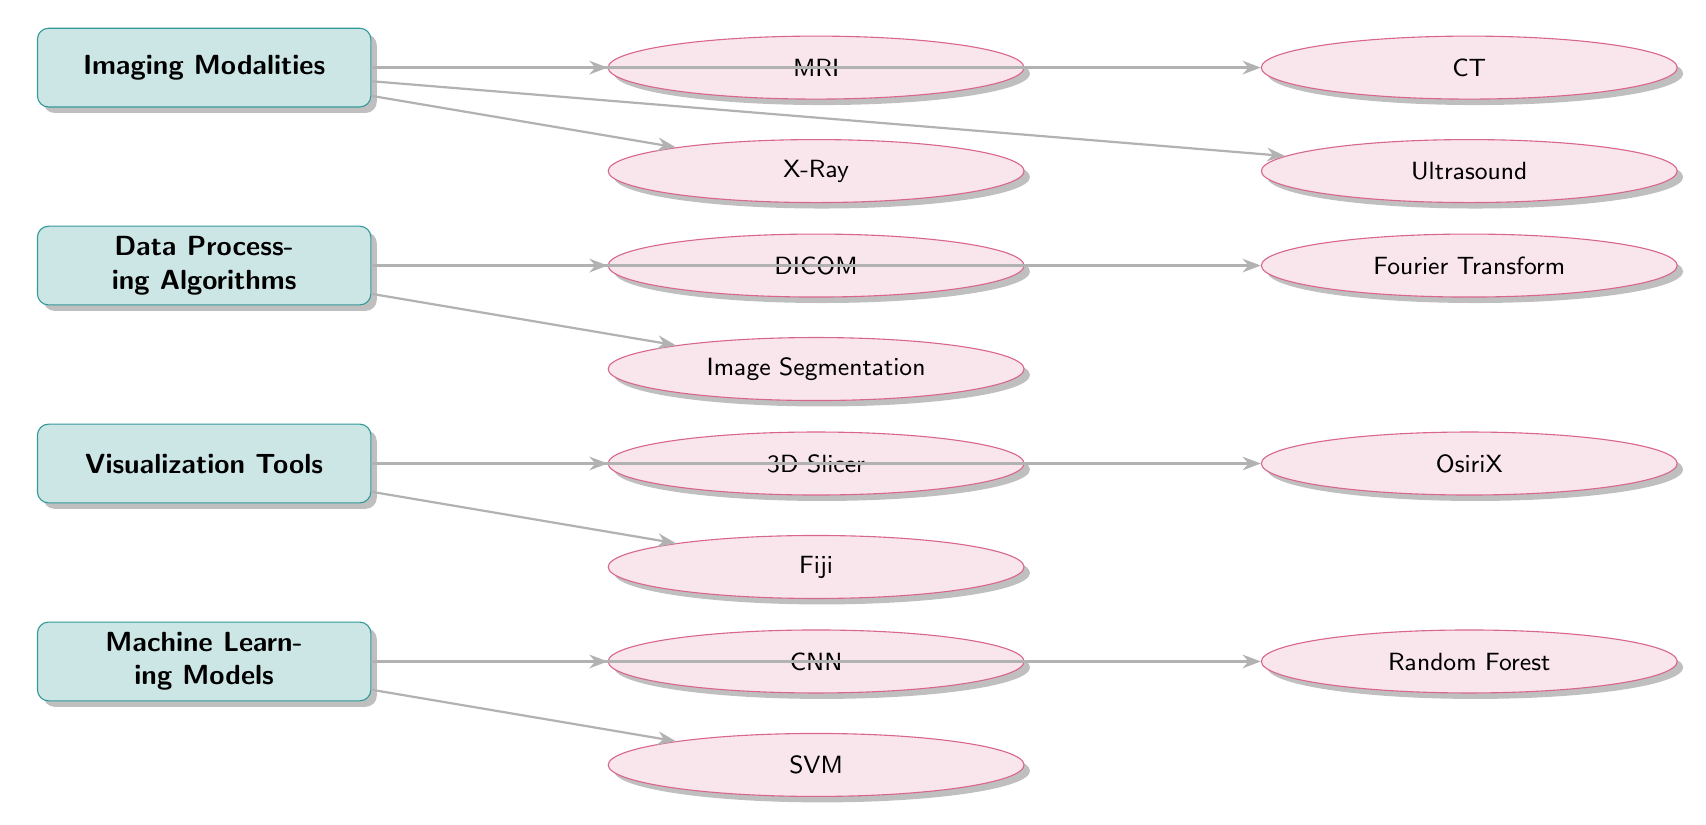What are the imaging modalities listed in the diagram? The diagram identifies four imaging modalities: MRI, CT, X-Ray, and Ultrasound. By examining the 'Imaging Modalities' category, the items adjacent to it reveal these modalities.
Answer: MRI, CT, X-Ray, Ultrasound How many data processing algorithms are shown? There are three data processing algorithms listed in the diagram: DICOM, Fourier Transform, and Image Segmentation. Counting the items under the 'Data Processing Algorithms' category confirms this.
Answer: 3 Which visualization tool is positioned at the far left? The visualization tool farthest to the left is 3D Slicer. Referring to the 'Visualization Tools' category, we observe the layout of the items to determine this position.
Answer: 3D Slicer Which machine learning model is shown below the CNN? The model below CNN is SVM. By examining the placement of items under the 'Machine Learning Models' category, we see that SVM is positioned directly below CNN.
Answer: SVM What connects the imaging modalities to data processing algorithms? The connection between imaging modalities and data processing algorithms is represented by lines (arrows). These arrows indicate the flow of data or processes from the imaging modalities to the data processing algorithms, which signifies a relationship.
Answer: Arrows Which visualization tool is next to OsiriX? The visualization tool next to OsiriX is Fiji. The items under 'Visualization Tools' can be scanned to identify that Fiji is located immediately below OsiriX.
Answer: Fiji How many machine learning models are depicted in the diagram? There are three machine learning models shown: CNN, Random Forest, and SVM. By counting the items in the 'Machine Learning Models' category, we arrive at this number.
Answer: 3 What are the two data processing algorithms listed in the diagram that are related to image analysis? The two data processing algorithms related to image analysis are Fourier Transform and Image Segmentation. They are specifically listed under the 'Data Processing Algorithms' category, which focuses on processing digital images.
Answer: Fourier Transform, Image Segmentation Which imaging modality is located directly below CT? The imaging modality directly below CT is Ultrasound. By checking the vertical position of items in the 'Imaging Modalities' category, we see Ultrasound falls directly under CT.
Answer: Ultrasound 